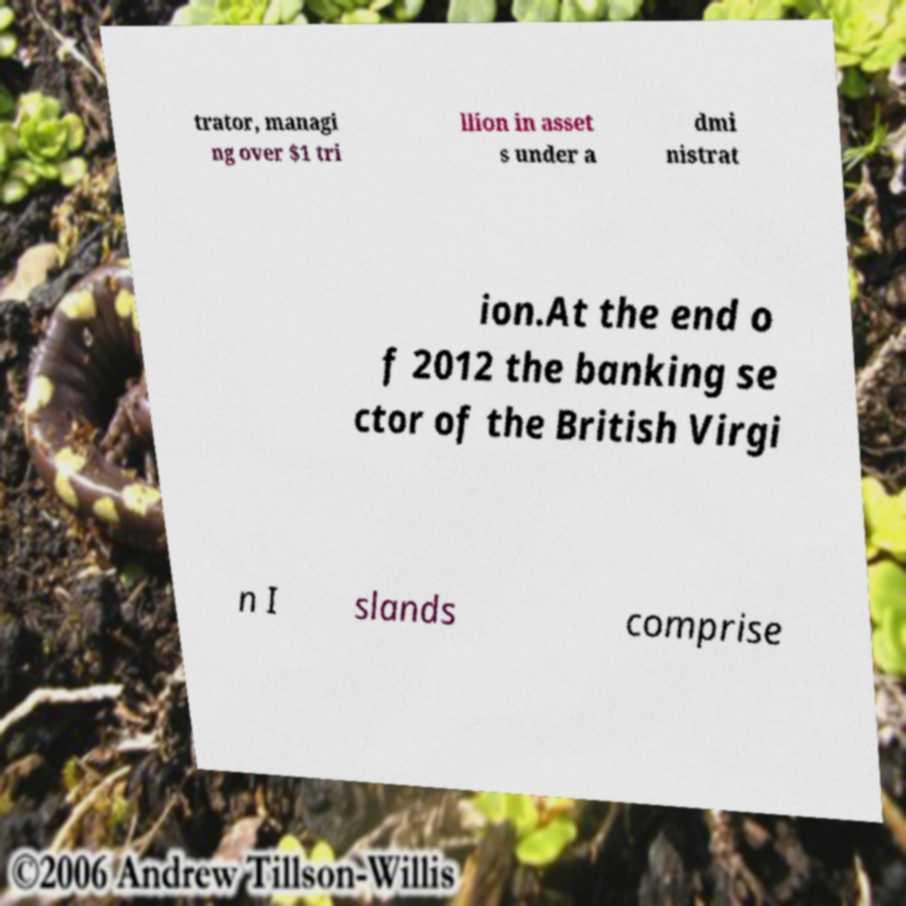For documentation purposes, I need the text within this image transcribed. Could you provide that? trator, managi ng over $1 tri llion in asset s under a dmi nistrat ion.At the end o f 2012 the banking se ctor of the British Virgi n I slands comprise 